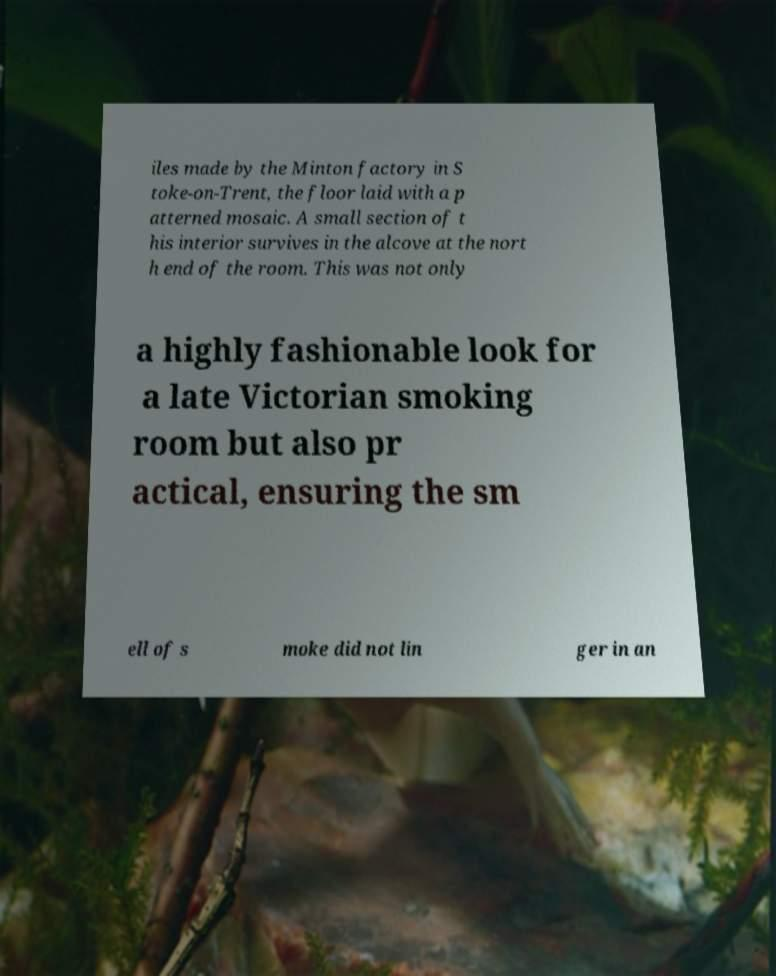Please identify and transcribe the text found in this image. iles made by the Minton factory in S toke-on-Trent, the floor laid with a p atterned mosaic. A small section of t his interior survives in the alcove at the nort h end of the room. This was not only a highly fashionable look for a late Victorian smoking room but also pr actical, ensuring the sm ell of s moke did not lin ger in an 